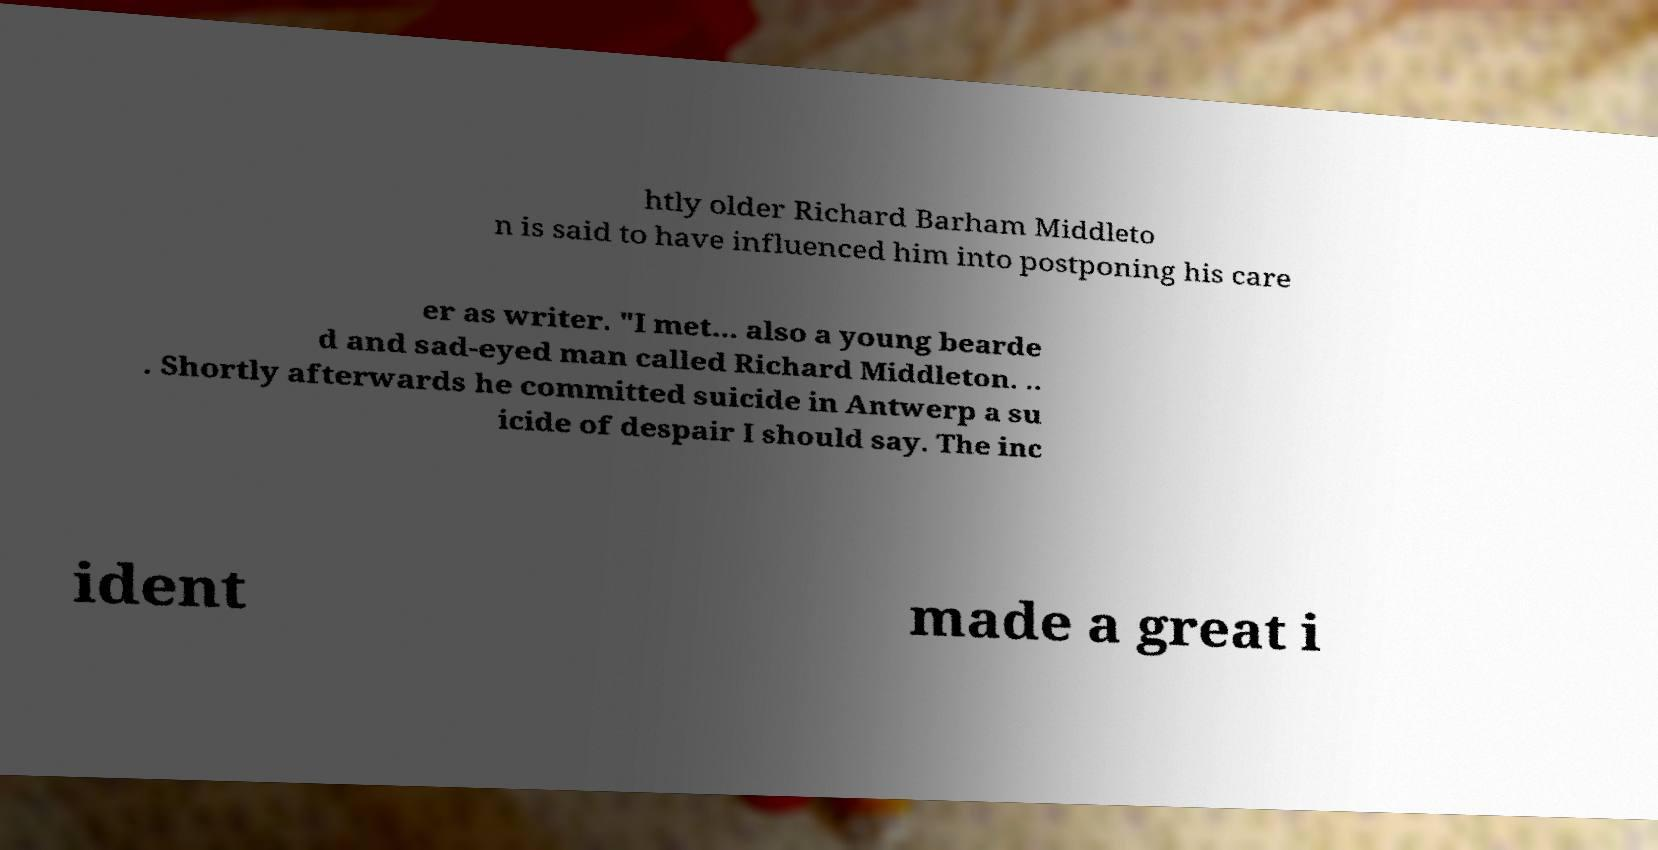Could you extract and type out the text from this image? htly older Richard Barham Middleto n is said to have influenced him into postponing his care er as writer. "I met... also a young bearde d and sad-eyed man called Richard Middleton. .. . Shortly afterwards he committed suicide in Antwerp a su icide of despair I should say. The inc ident made a great i 